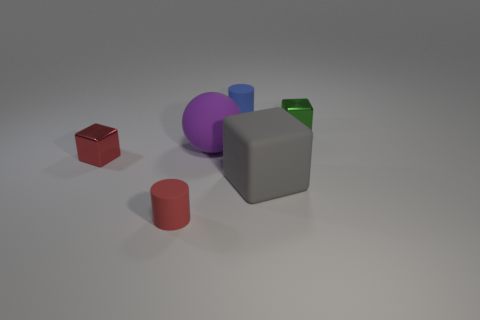What material is the tiny object that is behind the small red matte cylinder and in front of the ball?
Your answer should be very brief. Metal. How many tiny rubber things are in front of the sphere?
Provide a succinct answer. 1. Does the tiny cylinder on the right side of the purple matte sphere have the same material as the cube behind the small red metallic block?
Give a very brief answer. No. How many things are gray objects in front of the purple thing or tiny green metallic objects?
Your response must be concise. 2. Are there fewer big gray cubes behind the big ball than small red cylinders on the right side of the tiny red metal object?
Your answer should be compact. Yes. What number of other objects are there of the same size as the green metallic block?
Your answer should be compact. 3. Are the gray thing and the tiny red object behind the large matte block made of the same material?
Give a very brief answer. No. How many things are tiny shiny blocks behind the small red rubber cylinder or matte objects left of the gray object?
Give a very brief answer. 5. What is the color of the big matte cube?
Give a very brief answer. Gray. Is the number of tiny metallic objects that are left of the red metallic block less than the number of red cylinders?
Provide a short and direct response. Yes. 